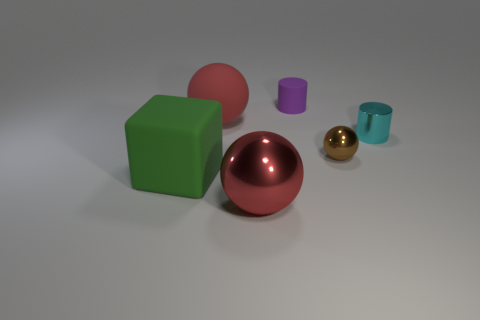Subtract all shiny balls. How many balls are left? 1 Add 4 green matte spheres. How many objects exist? 10 Subtract all cylinders. How many objects are left? 4 Subtract 1 brown balls. How many objects are left? 5 Subtract all large red matte balls. Subtract all big gray rubber cylinders. How many objects are left? 5 Add 2 tiny balls. How many tiny balls are left? 3 Add 3 tiny brown metal things. How many tiny brown metal things exist? 4 